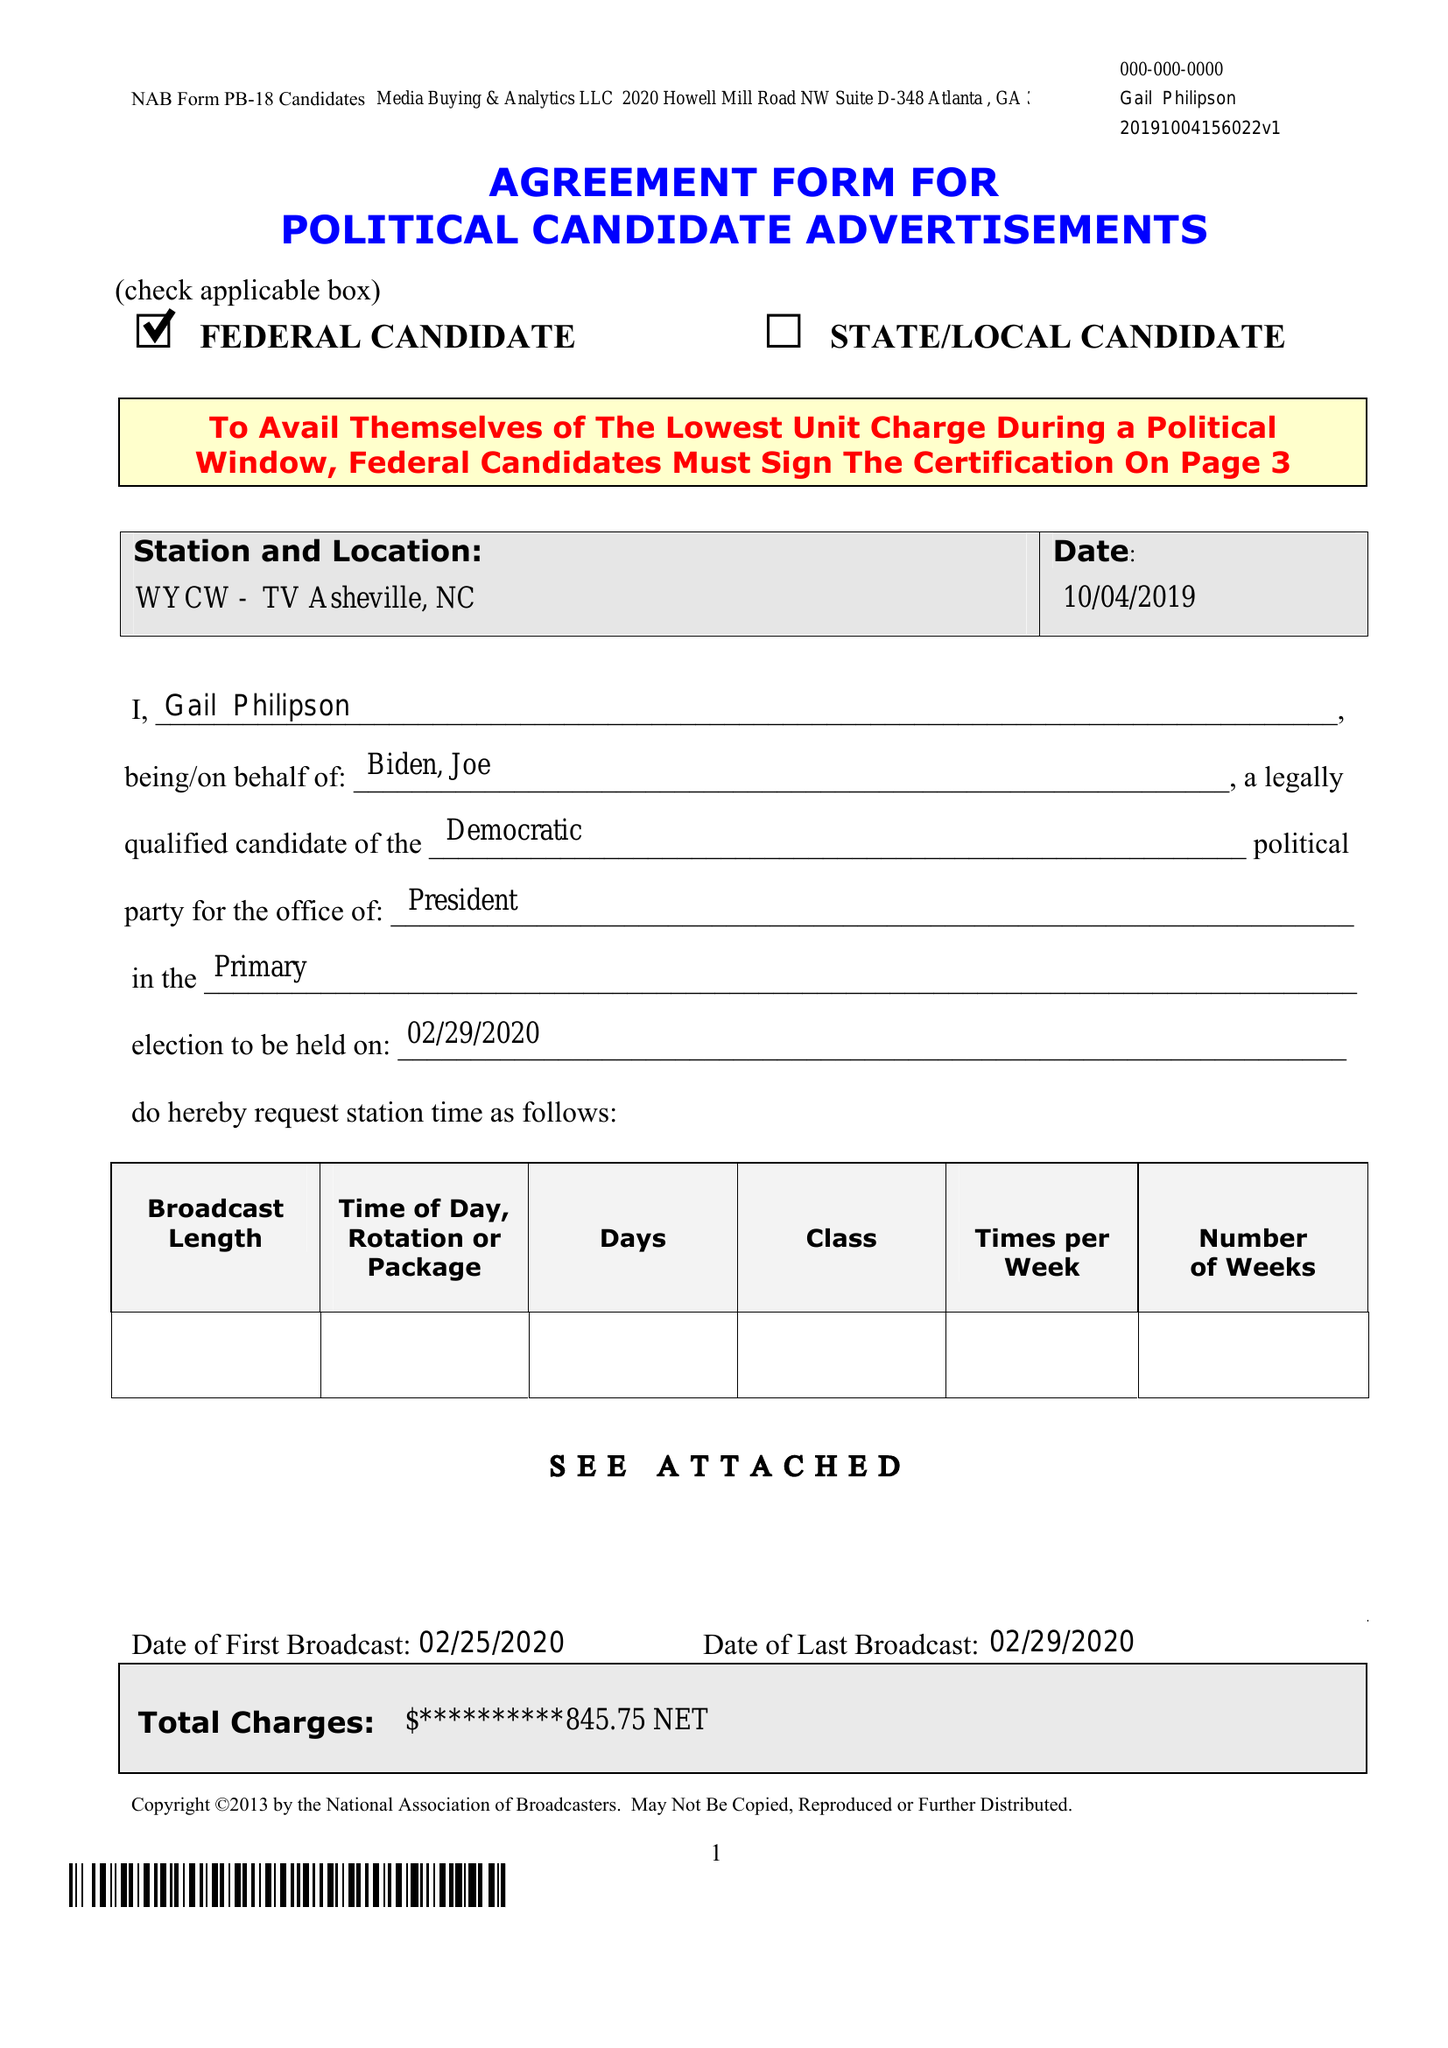What is the value for the advertiser?
Answer the question using a single word or phrase. None 